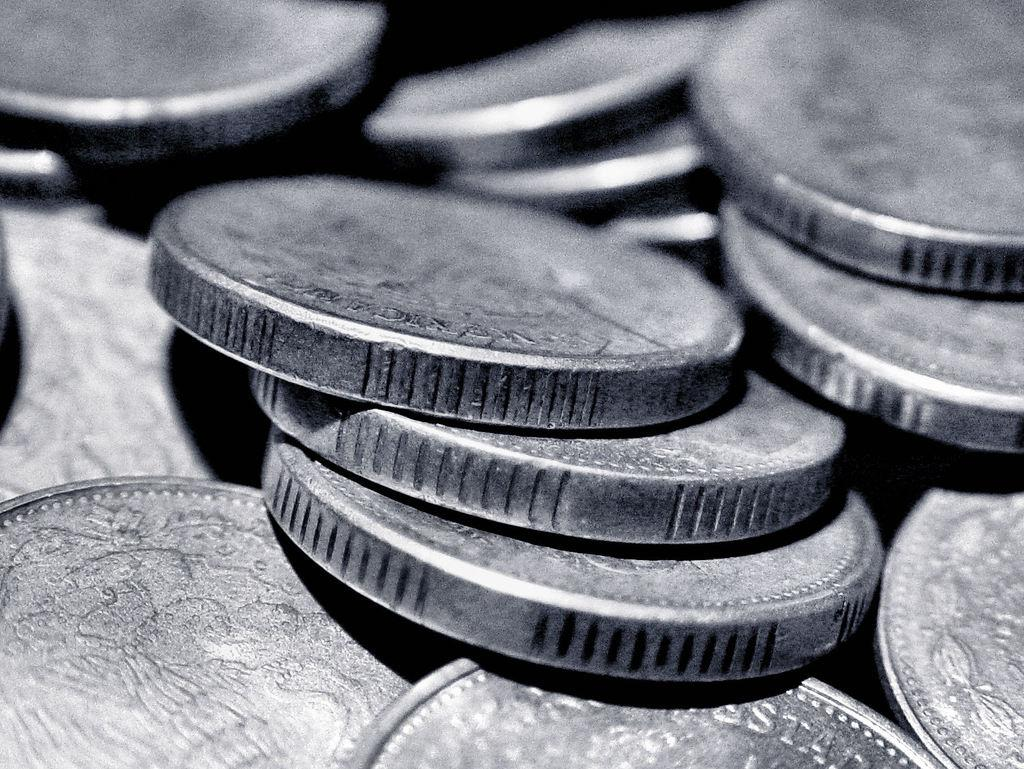What type of objects are present in the image? There are silver coins in the image. Can you describe the appearance of the objects? The coins are silver in color. Are there any other objects or elements in the image besides the coins? The provided facts do not mention any other objects or elements in the image. What type of writer is standing on the stage holding a bottle in the image? There is no writer, bottle, or stage present in the image; it only contains silver coins. 